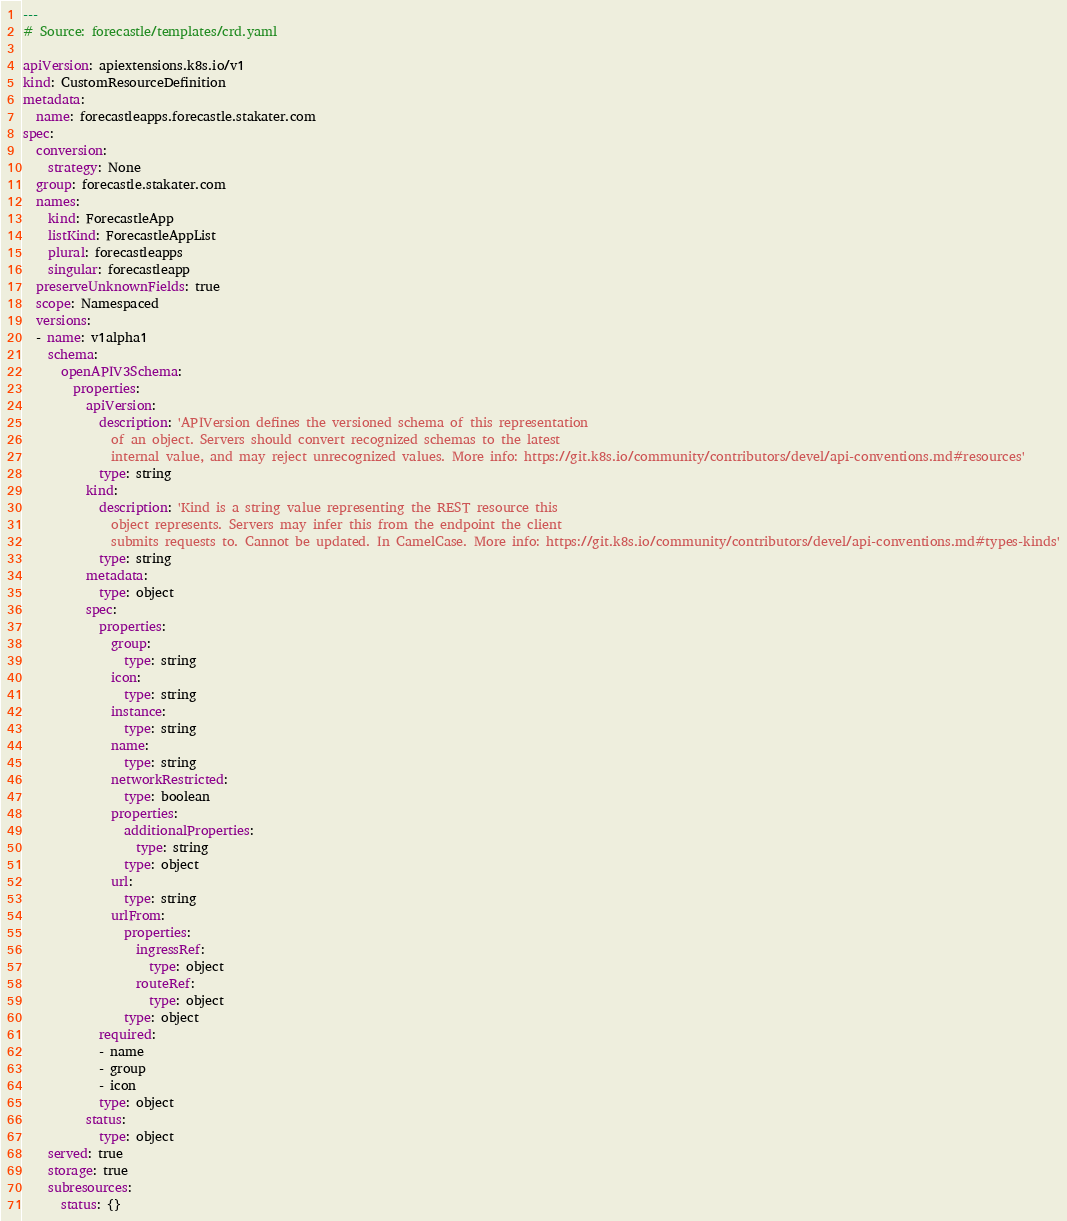Convert code to text. <code><loc_0><loc_0><loc_500><loc_500><_YAML_>---
# Source: forecastle/templates/crd.yaml

apiVersion: apiextensions.k8s.io/v1
kind: CustomResourceDefinition
metadata:
  name: forecastleapps.forecastle.stakater.com
spec:
  conversion:
    strategy: None
  group: forecastle.stakater.com
  names:
    kind: ForecastleApp
    listKind: ForecastleAppList
    plural: forecastleapps
    singular: forecastleapp
  preserveUnknownFields: true
  scope: Namespaced
  versions:
  - name: v1alpha1
    schema:
      openAPIV3Schema:
        properties:
          apiVersion:
            description: 'APIVersion defines the versioned schema of this representation
              of an object. Servers should convert recognized schemas to the latest
              internal value, and may reject unrecognized values. More info: https://git.k8s.io/community/contributors/devel/api-conventions.md#resources'
            type: string
          kind:
            description: 'Kind is a string value representing the REST resource this
              object represents. Servers may infer this from the endpoint the client
              submits requests to. Cannot be updated. In CamelCase. More info: https://git.k8s.io/community/contributors/devel/api-conventions.md#types-kinds'
            type: string
          metadata:
            type: object
          spec:
            properties:
              group:
                type: string
              icon:
                type: string
              instance:
                type: string
              name:
                type: string
              networkRestricted:
                type: boolean
              properties:
                additionalProperties:
                  type: string
                type: object
              url:
                type: string
              urlFrom:
                properties:
                  ingressRef:
                    type: object
                  routeRef:
                    type: object
                type: object
            required:
            - name
            - group
            - icon
            type: object
          status:
            type: object
    served: true
    storage: true
    subresources:
      status: {}
</code> 